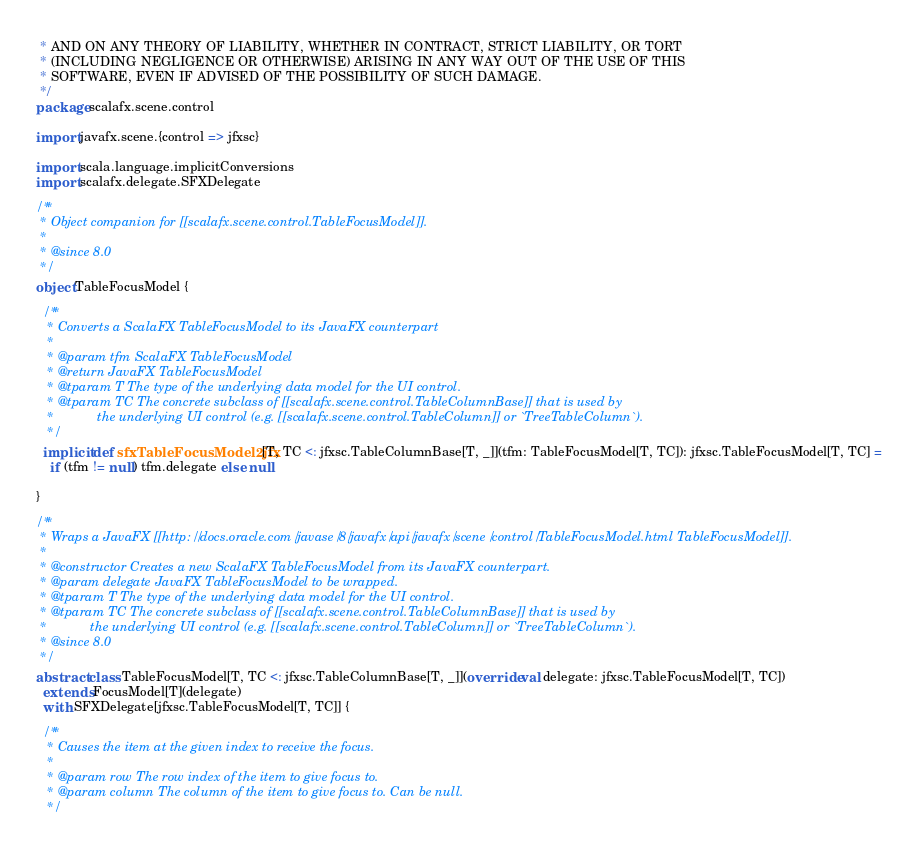Convert code to text. <code><loc_0><loc_0><loc_500><loc_500><_Scala_> * AND ON ANY THEORY OF LIABILITY, WHETHER IN CONTRACT, STRICT LIABILITY, OR TORT
 * (INCLUDING NEGLIGENCE OR OTHERWISE) ARISING IN ANY WAY OUT OF THE USE OF THIS
 * SOFTWARE, EVEN IF ADVISED OF THE POSSIBILITY OF SUCH DAMAGE.
 */
package scalafx.scene.control

import javafx.scene.{control => jfxsc}

import scala.language.implicitConversions
import scalafx.delegate.SFXDelegate

/**
 * Object companion for [[scalafx.scene.control.TableFocusModel]].
 *
 * @since 8.0
 */
object TableFocusModel {

  /**
   * Converts a ScalaFX TableFocusModel to its JavaFX counterpart
   *
   * @param tfm ScalaFX TableFocusModel
   * @return JavaFX TableFocusModel
   * @tparam T The type of the underlying data model for the UI control.
   * @tparam TC The concrete subclass of [[scalafx.scene.control.TableColumnBase]] that is used by
   *            the underlying UI control (e.g. [[scalafx.scene.control.TableColumn]] or `TreeTableColumn`).
   */
  implicit def sfxTableFocusModel2jfx[T, TC <: jfxsc.TableColumnBase[T, _]](tfm: TableFocusModel[T, TC]): jfxsc.TableFocusModel[T, TC] =
    if (tfm != null) tfm.delegate else null

}

/**
 * Wraps a JavaFX [[http://docs.oracle.com/javase/8/javafx/api/javafx/scene/control/TableFocusModel.html TableFocusModel]].
 *
 * @constructor Creates a new ScalaFX TableFocusModel from its JavaFX counterpart.
 * @param delegate JavaFX TableFocusModel to be wrapped.
 * @tparam T The type of the underlying data model for the UI control.
 * @tparam TC The concrete subclass of [[scalafx.scene.control.TableColumnBase]] that is used by
 *            the underlying UI control (e.g. [[scalafx.scene.control.TableColumn]] or `TreeTableColumn`).
 * @since 8.0
 */
abstract class TableFocusModel[T, TC <: jfxsc.TableColumnBase[T, _]](override val delegate: jfxsc.TableFocusModel[T, TC])
  extends FocusModel[T](delegate)
  with SFXDelegate[jfxsc.TableFocusModel[T, TC]] {

  /**
   * Causes the item at the given index to receive the focus.
   *
   * @param row The row index of the item to give focus to.
   * @param column The column of the item to give focus to. Can be null.
   */</code> 